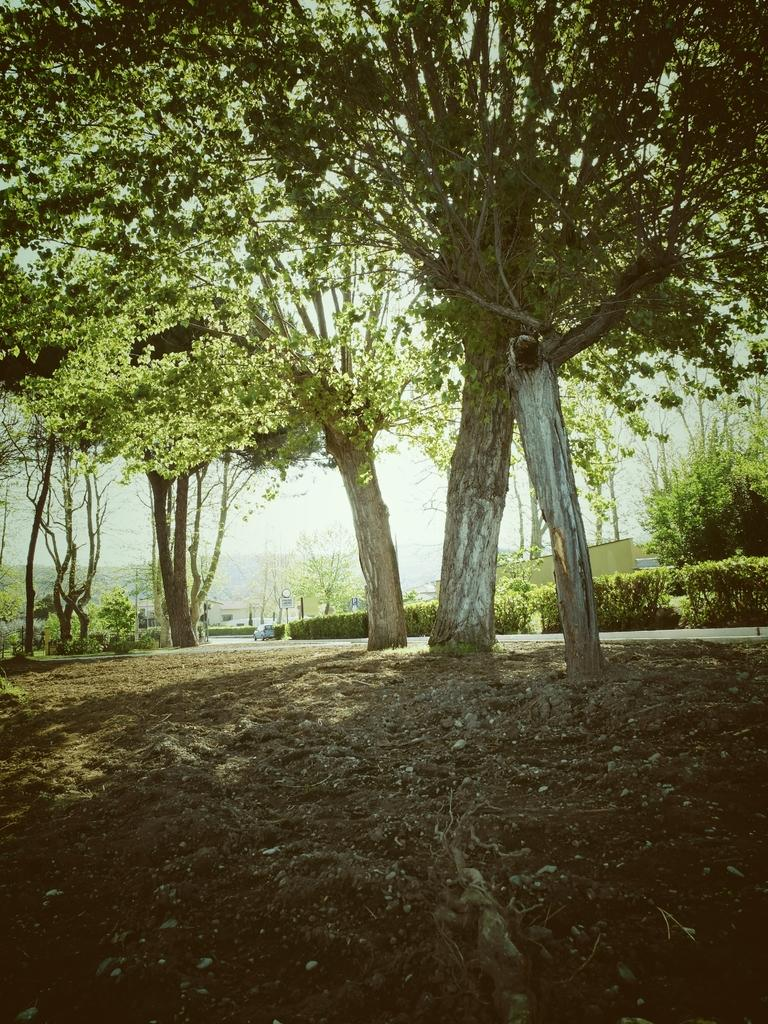What is located in the middle of the image? There are trees in the middle of the image. What can be seen at the bottom of the image? The bottom of the image contains soil. How many zinc plants are growing in the soil at the bottom of the image? There is no mention of zinc plants in the image; it features trees and soil. What type of tomatoes can be seen growing on the trees in the image? There are no tomatoes present in the image; it only features trees and soil. 